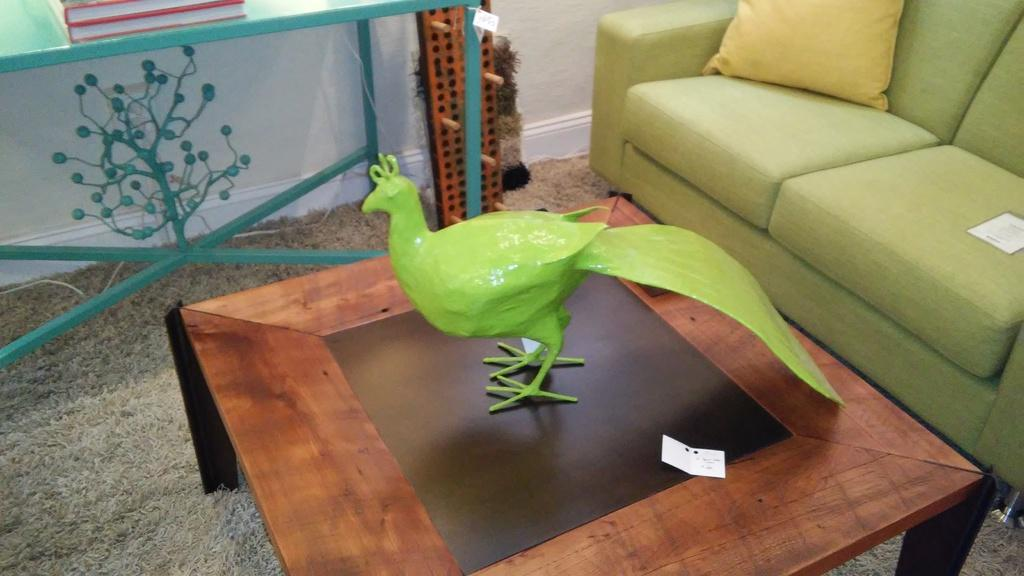What object is on the table in the image? There is a toy bird on a table in the image. What type of furniture is located at the right side of the image? There is a couch at the right side of the image. What is on the couch in the image? There is a pillow on the couch. What can be seen in the background of the image? There is a wall in the background of the image. What else is on the table besides the toy bird? There are books on the table in the image. How does the toothbrush turn on in the image? There is no toothbrush present in the image, so it cannot be turned on. 